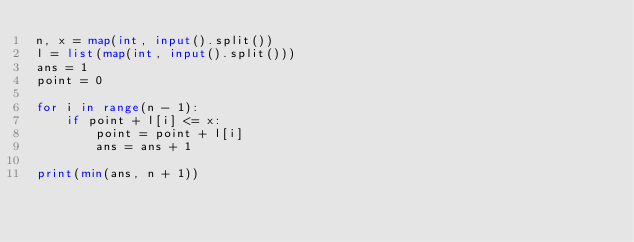Convert code to text. <code><loc_0><loc_0><loc_500><loc_500><_Python_>n, x = map(int, input().split())
l = list(map(int, input().split()))
ans = 1
point = 0

for i in range(n - 1):
    if point + l[i] <= x:
        point = point + l[i]
        ans = ans + 1

print(min(ans, n + 1))</code> 